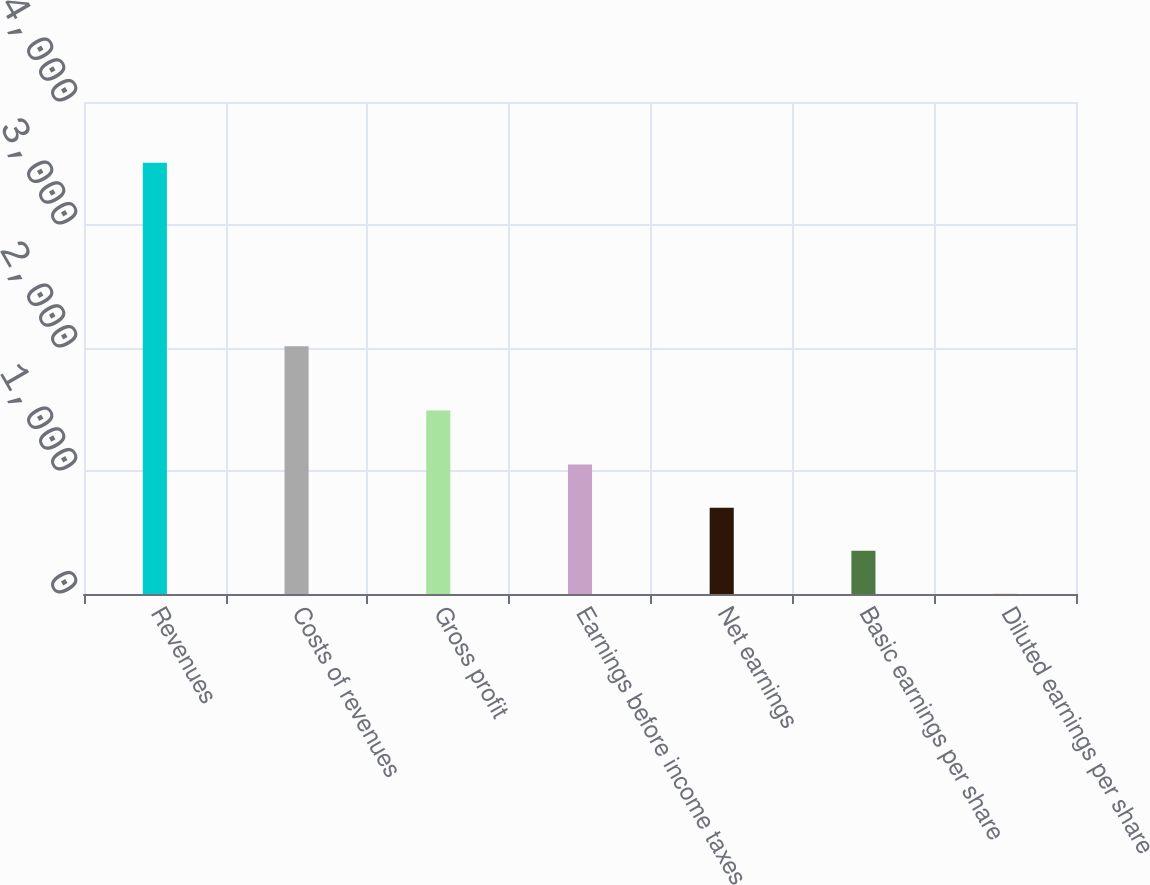Convert chart to OTSL. <chart><loc_0><loc_0><loc_500><loc_500><bar_chart><fcel>Revenues<fcel>Costs of revenues<fcel>Gross profit<fcel>Earnings before income taxes<fcel>Net earnings<fcel>Basic earnings per share<fcel>Diluted earnings per share<nl><fcel>3505.9<fcel>2013.7<fcel>1492.2<fcel>1052.65<fcel>702.19<fcel>351.73<fcel>1.27<nl></chart> 